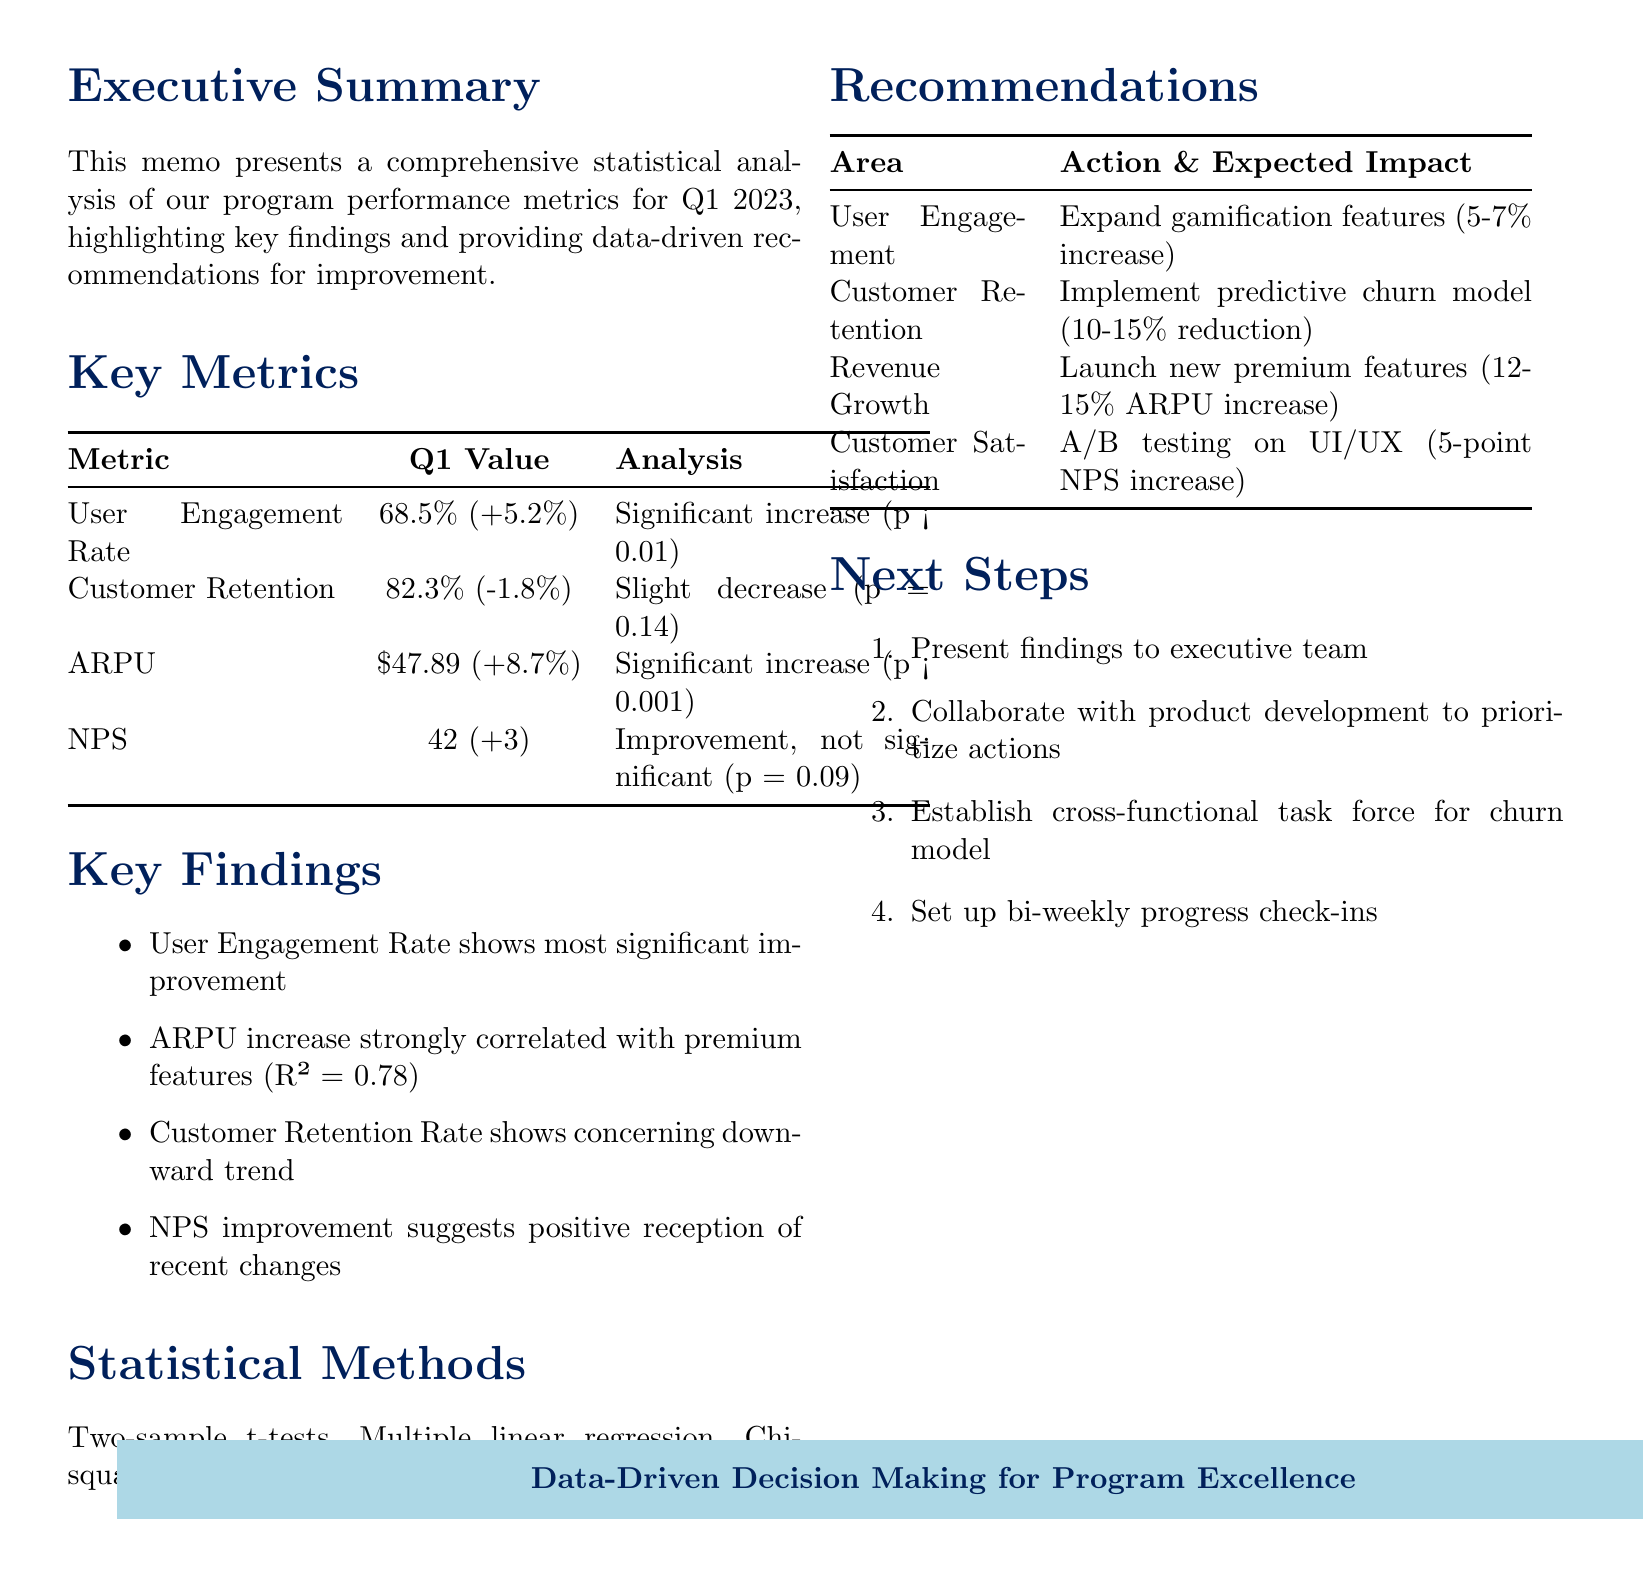what is the User Engagement Rate for Q1 2023? The User Engagement Rate for Q1 2023 is specified in the key metrics section as 68.5%.
Answer: 68.5% what is the Year-over-Year Change for Average Revenue Per User (ARPU)? The Year-over-Year Change for ARPU is highlighted as +8.7%.
Answer: +8.7% what statistical test was used for year-over-year comparisons? The document mentions that two-sample t-tests were used for year-over-year comparisons.
Answer: Two-sample t-tests which area has the highest expected impact recommendation? The revenue growth recommendation states an expected impact of 12-15% increase in ARPU, which is the highest among all areas.
Answer: Revenue Growth what is the expected impact of expanding gamification features? The expected impact of expanding gamification features is indicated to be a 5-7% increase in overall engagement rate.
Answer: 5-7% increase what method was used to analyze the correlation between premium features and ARPU? Multiple linear regression was used to analyze the correlation between premium features and ARPU, according to the statistical methods section.
Answer: Multiple linear regression what aspect showed a concerning trend in the key findings? The customer retention rate showed a concerning downward trend according to the key findings in the memo.
Answer: Customer Retention Rate what is the implementation timeframe for the new premium features recommendation? The implementation timeframe for developing and launching two new premium features is stated as Q2-Q3 2023.
Answer: Q2-Q3 2023 how often will progress check-ins be scheduled according to next steps? Progress check-ins are planned to be scheduled bi-weekly, as outlined in the next steps section.
Answer: Bi-weekly 